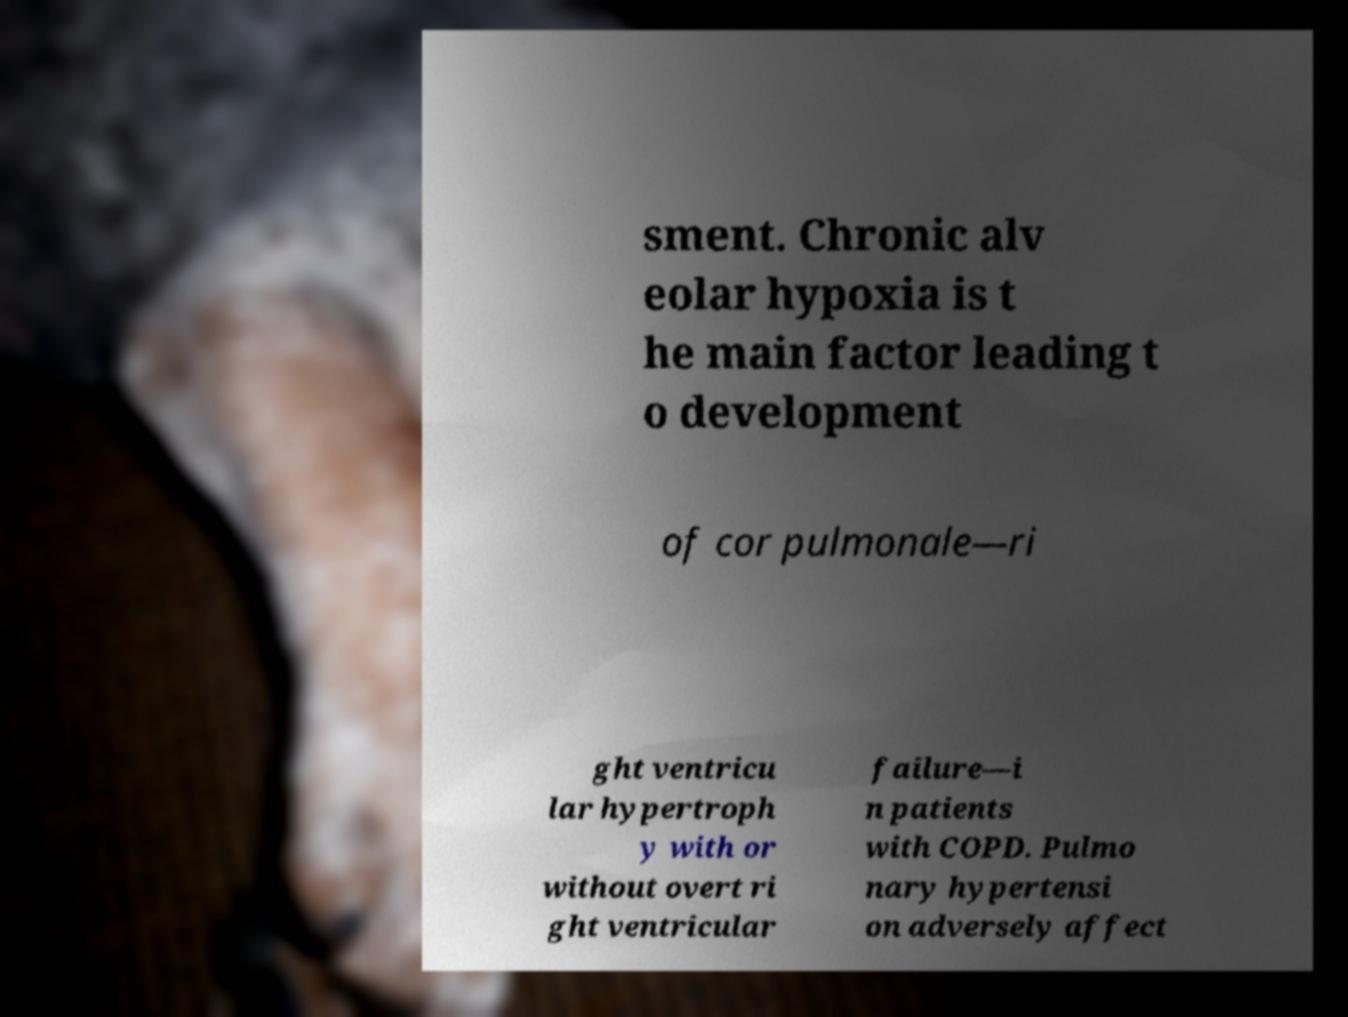Please identify and transcribe the text found in this image. sment. Chronic alv eolar hypoxia is t he main factor leading t o development of cor pulmonale—ri ght ventricu lar hypertroph y with or without overt ri ght ventricular failure—i n patients with COPD. Pulmo nary hypertensi on adversely affect 